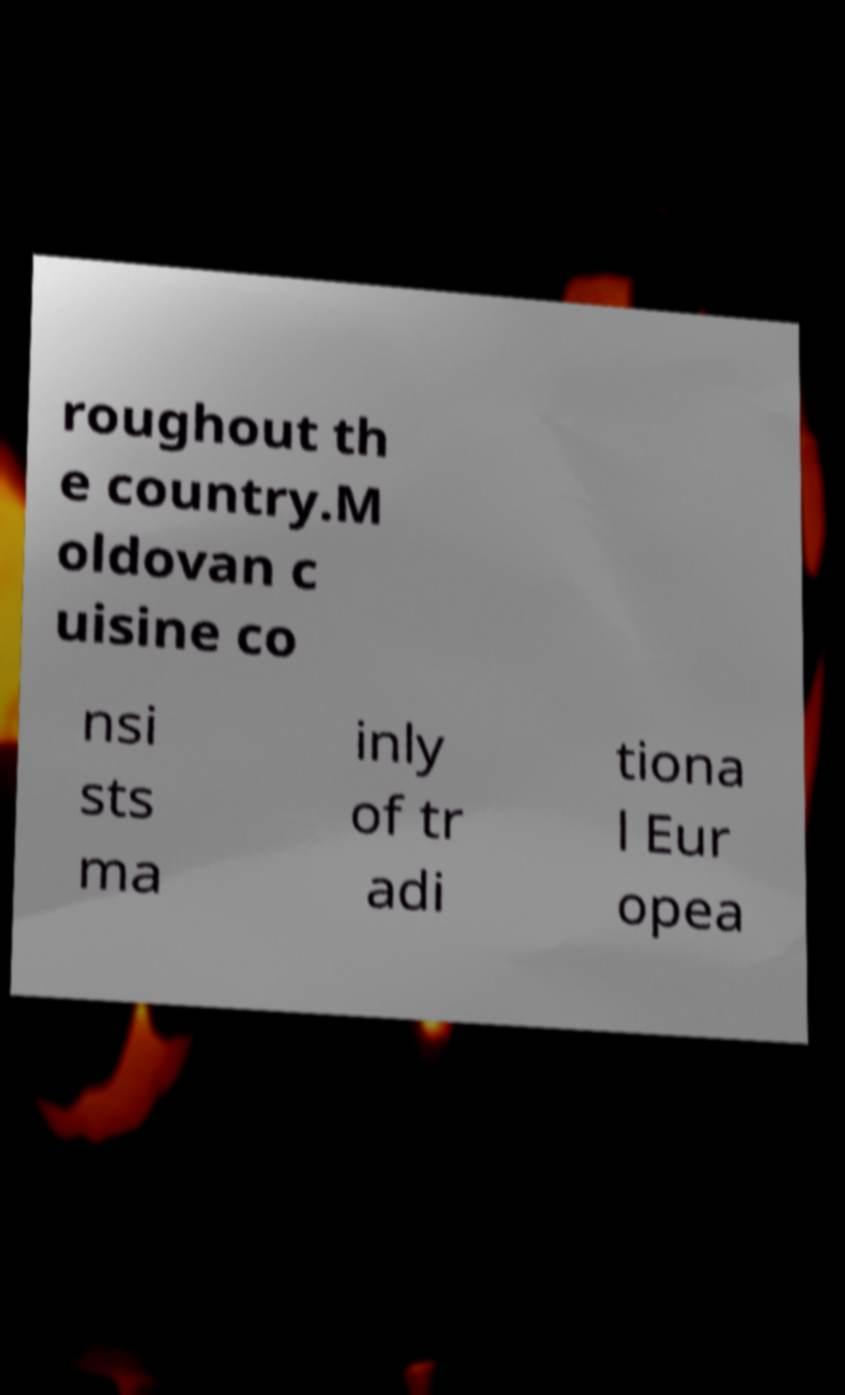Could you assist in decoding the text presented in this image and type it out clearly? roughout th e country.M oldovan c uisine co nsi sts ma inly of tr adi tiona l Eur opea 